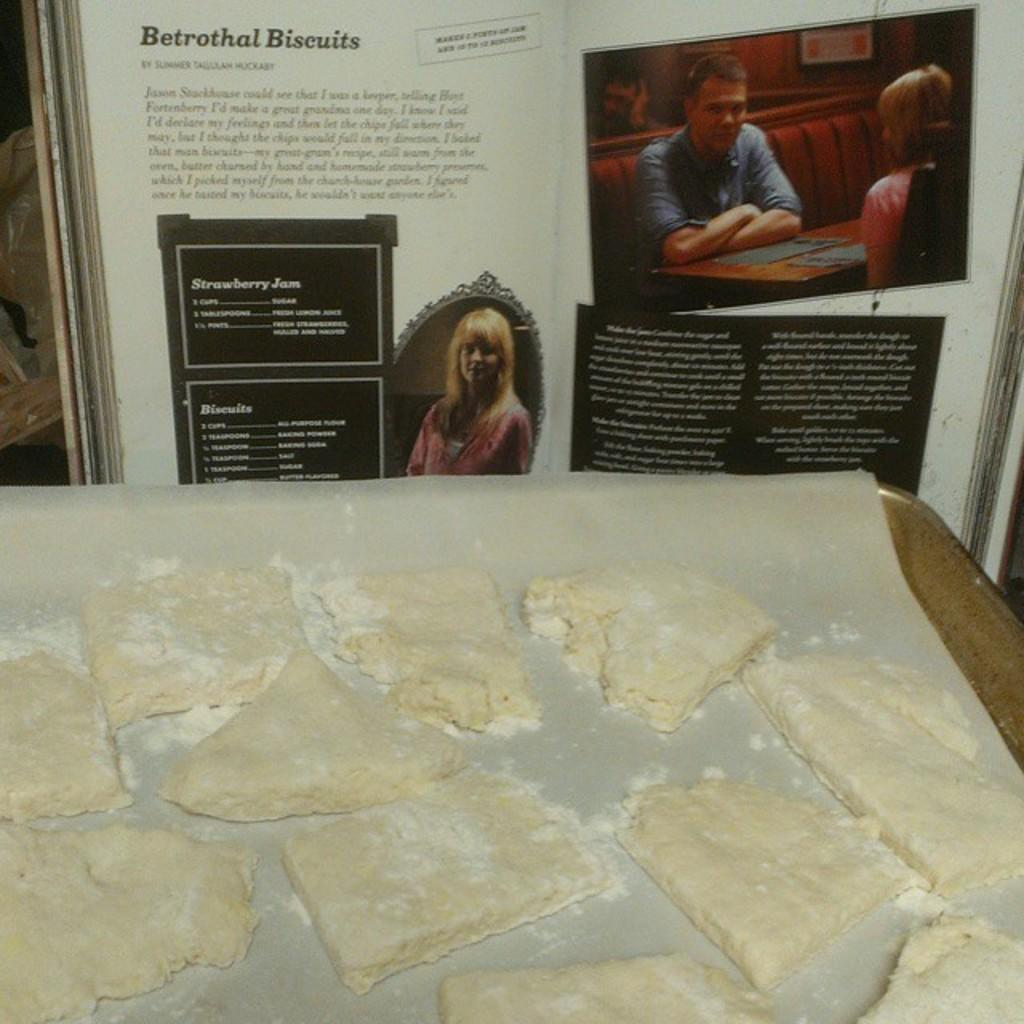What is the food item placed on in the image? The food item is placed on a paper in the image. How is the food item supported or presented? The food item is on a tray in the image. What can be seen in the background of the image? There is a book in the background of the image. What type of flight experience is depicted in the image? There is no flight experience depicted in the image; it features a food item on a paper and a tray, with a book in the background. 